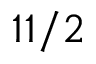Convert formula to latex. <formula><loc_0><loc_0><loc_500><loc_500>1 1 / 2</formula> 